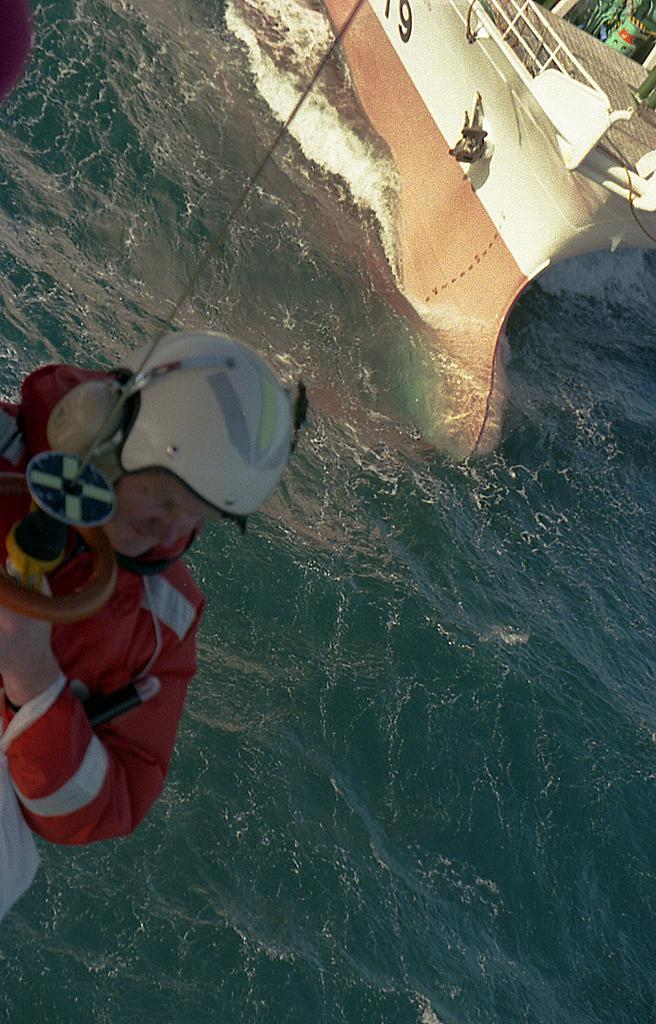What is the main subject in the foreground of the image? There is a man in the foreground of the image. What is the man wearing on his head? The man is wearing a helmet. What color is the coat the man is wearing? The man is wearing a red coat. What object is the man holding in his hand? The man is holding a sword-like object in his hand. What can be seen in the background of the image? There is water and a ship visible in the background of the image. What language is the scarecrow speaking in the image? There is no scarecrow present in the image, so it is not possible to determine what language it might be speaking. 